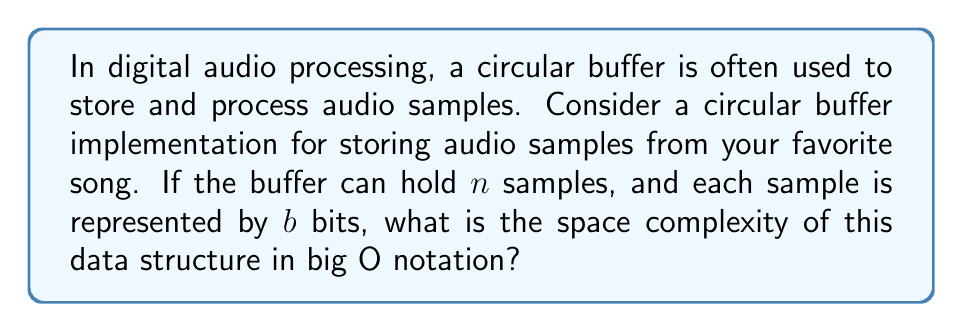Show me your answer to this math problem. Let's break this down step-by-step:

1) The circular buffer is designed to store $n$ audio samples.

2) Each sample is represented by $b$ bits.

3) To calculate the total space required, we multiply the number of samples by the size of each sample:

   Total space = $n * b$ bits

4) In big O notation, we're interested in how the space requirements grow with respect to the input size. In this case, our input size is $n$ (the number of samples).

5) The number of bits per sample ($b$) is typically a constant value determined by the audio quality (e.g., 16 bits for CD quality, 24 bits for high-resolution audio). In big O analysis, we drop constant factors.

6) Therefore, the space complexity grows linearly with $n$.

7) We express this linear growth in big O notation as $O(n)$.

This means that as the number of samples in our buffer increases, the space required increases proportionally. This efficient use of space is one reason circular buffers are popular in audio processing, allowing us to store and manipulate segments of our favorite songs without excessive memory usage.
Answer: $O(n)$ 